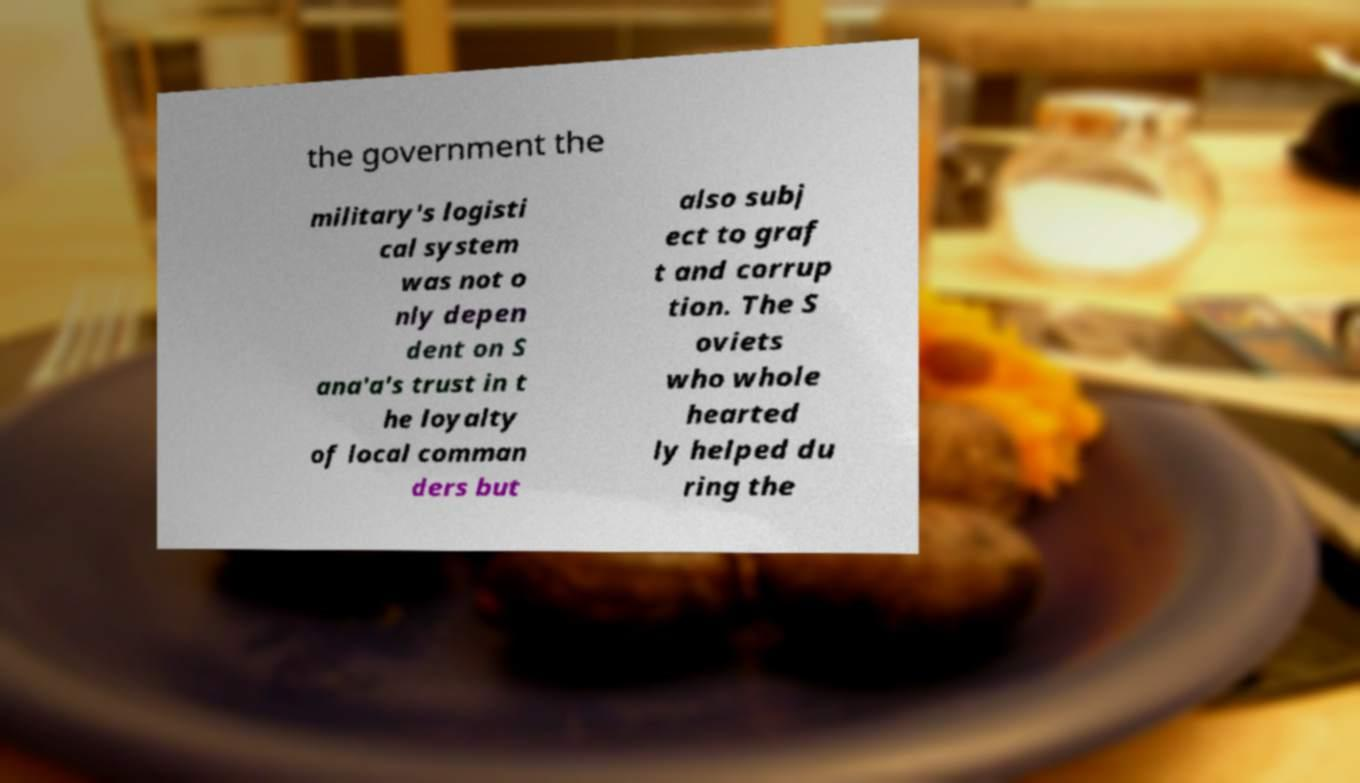There's text embedded in this image that I need extracted. Can you transcribe it verbatim? the government the military's logisti cal system was not o nly depen dent on S ana'a's trust in t he loyalty of local comman ders but also subj ect to graf t and corrup tion. The S oviets who whole hearted ly helped du ring the 